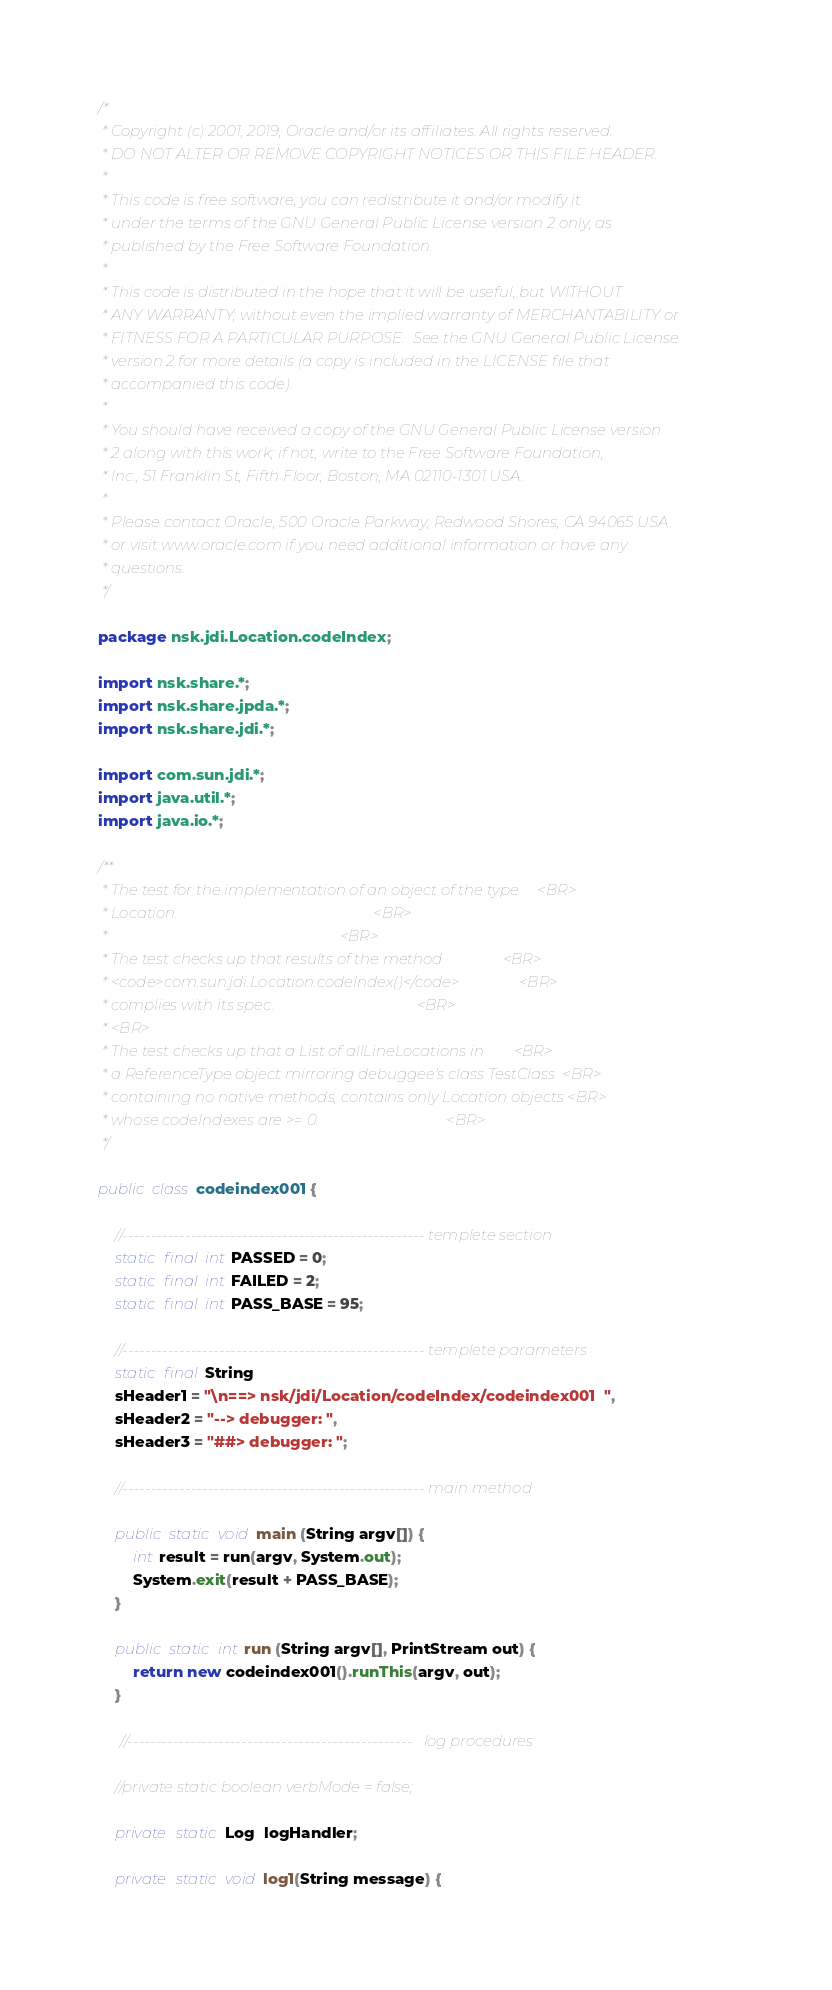<code> <loc_0><loc_0><loc_500><loc_500><_Java_>/*
 * Copyright (c) 2001, 2019, Oracle and/or its affiliates. All rights reserved.
 * DO NOT ALTER OR REMOVE COPYRIGHT NOTICES OR THIS FILE HEADER.
 *
 * This code is free software; you can redistribute it and/or modify it
 * under the terms of the GNU General Public License version 2 only, as
 * published by the Free Software Foundation.
 *
 * This code is distributed in the hope that it will be useful, but WITHOUT
 * ANY WARRANTY; without even the implied warranty of MERCHANTABILITY or
 * FITNESS FOR A PARTICULAR PURPOSE.  See the GNU General Public License
 * version 2 for more details (a copy is included in the LICENSE file that
 * accompanied this code).
 *
 * You should have received a copy of the GNU General Public License version
 * 2 along with this work; if not, write to the Free Software Foundation,
 * Inc., 51 Franklin St, Fifth Floor, Boston, MA 02110-1301 USA.
 *
 * Please contact Oracle, 500 Oracle Parkway, Redwood Shores, CA 94065 USA
 * or visit www.oracle.com if you need additional information or have any
 * questions.
 */

package nsk.jdi.Location.codeIndex;

import nsk.share.*;
import nsk.share.jpda.*;
import nsk.share.jdi.*;

import com.sun.jdi.*;
import java.util.*;
import java.io.*;

/**
 * The test for the implementation of an object of the type     <BR>
 * Location.                                                    <BR>
 *                                                              <BR>
 * The test checks up that results of the method                <BR>
 * <code>com.sun.jdi.Location.codeIndex()</code>                <BR>
 * complies with its spec.                                      <BR>
 * <BR>
 * The test checks up that a List of allLineLocations in        <BR>
 * a ReferenceType object mirroring debuggee's class TestClass  <BR>
 * containing no native methods, contains only Location objects <BR>
 * whose codeIndexes are >= 0.                                  <BR>
 */

public class codeindex001 {

    //----------------------------------------------------- templete section
    static final int PASSED = 0;
    static final int FAILED = 2;
    static final int PASS_BASE = 95;

    //----------------------------------------------------- templete parameters
    static final String
    sHeader1 = "\n==> nsk/jdi/Location/codeIndex/codeindex001  ",
    sHeader2 = "--> debugger: ",
    sHeader3 = "##> debugger: ";

    //----------------------------------------------------- main method

    public static void main (String argv[]) {
        int result = run(argv, System.out);
        System.exit(result + PASS_BASE);
    }

    public static int run (String argv[], PrintStream out) {
        return new codeindex001().runThis(argv, out);
    }

     //--------------------------------------------------   log procedures

    //private static boolean verbMode = false;

    private static Log  logHandler;

    private static void log1(String message) {</code> 